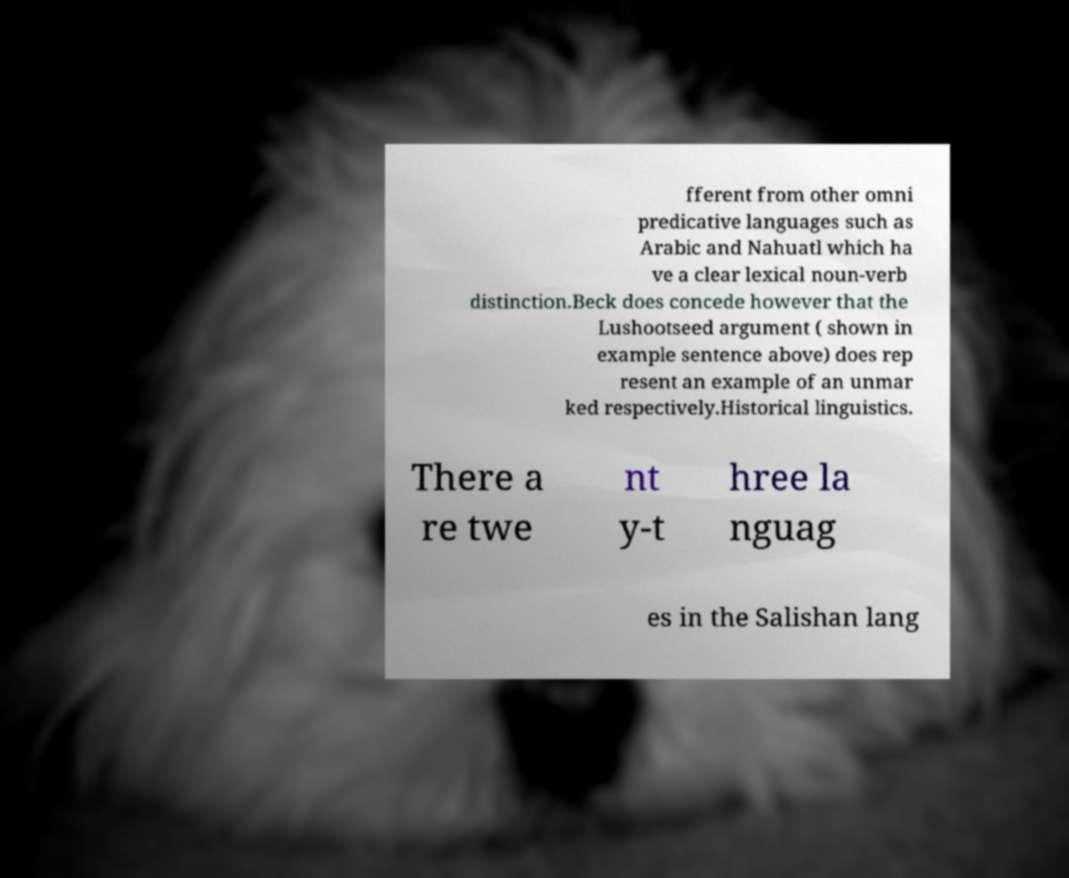Please read and relay the text visible in this image. What does it say? fferent from other omni predicative languages such as Arabic and Nahuatl which ha ve a clear lexical noun-verb distinction.Beck does concede however that the Lushootseed argument ( shown in example sentence above) does rep resent an example of an unmar ked respectively.Historical linguistics. There a re twe nt y-t hree la nguag es in the Salishan lang 